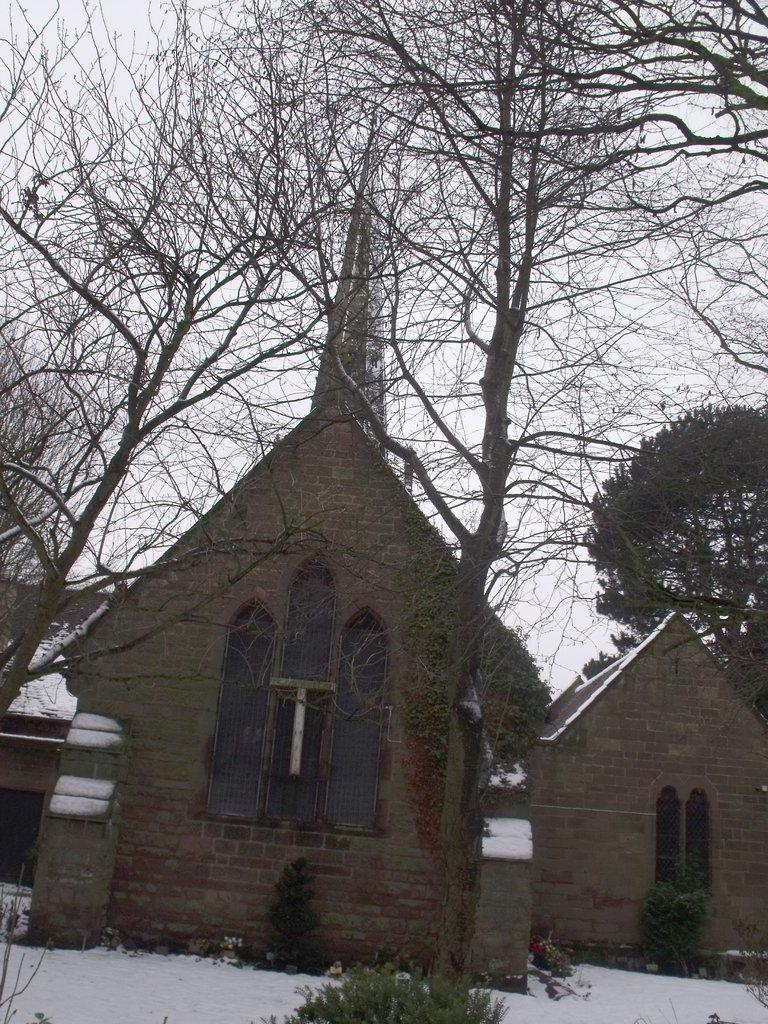What type of structures can be seen in the image? There are houses in the image. What is covering the ground in the image? There is: There is snow in the image. What type of vegetation is present in the image? There are trees in the image. What is visible in the background of the image? The sky is visible in the image. What type of dinner is being served in the image? There is no dinner present in the image; it features houses, snow, trees, and the sky. How many cents are visible in the image? There are no cents present in the image. 